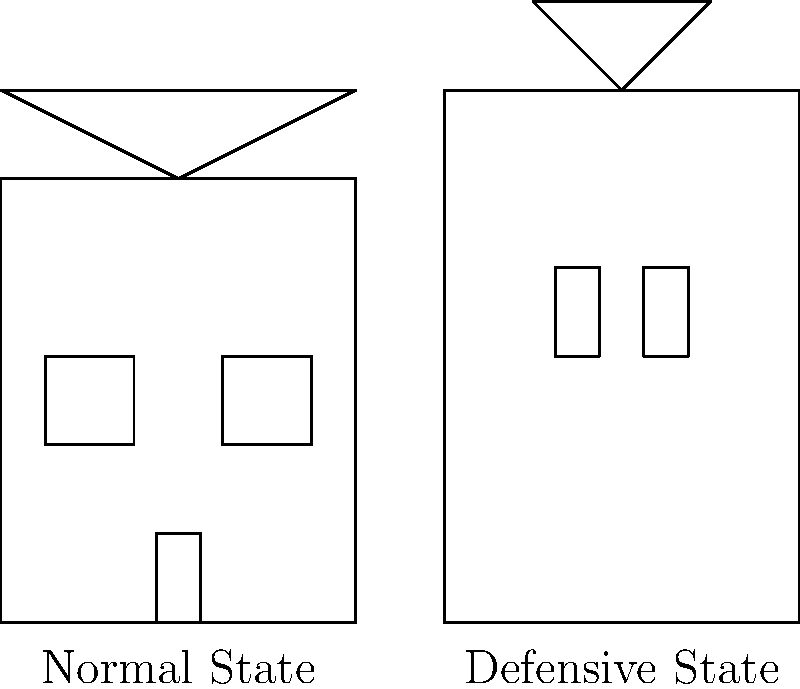In the context of a multi-purpose building inspired by the movie "Cowboys & Aliens," what key structural element allows for the seamless transformation between the normal state and the defensive state, as shown in the architectural drawings? To answer this question, let's analyze the key differences between the normal state and the defensive state of the building:

1. Normal State:
   - Standard rectangular building shape
   - Sloped roof
   - Regular windows and door

2. Defensive State:
   - Taller, more fortified structure
   - Flat top with a turret
   - Arrow slits instead of windows

The key structural element that allows for this transformation is a set of retractable walls. This system would work as follows:

1. The outer walls of the normal state building are designed to extend vertically.
2. The roof is likely segmented and can fold or retract into the extended walls.
3. The windows are designed with shutters that can close and form arrow slits.
4. The turret at the top is likely a collapsible structure that can be raised from within the building.

This retractable wall system allows the building to quickly transform from a normal state to a defensive state, providing protection against potential alien attacks while maintaining the functionality of a regular building during peaceful times.
Answer: Retractable walls 